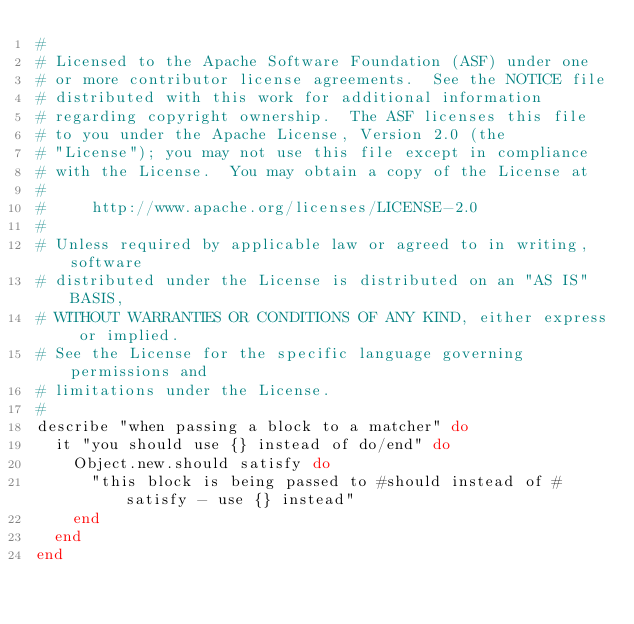<code> <loc_0><loc_0><loc_500><loc_500><_Ruby_>#
# Licensed to the Apache Software Foundation (ASF) under one
# or more contributor license agreements.  See the NOTICE file
# distributed with this work for additional information
# regarding copyright ownership.  The ASF licenses this file
# to you under the Apache License, Version 2.0 (the
# "License"); you may not use this file except in compliance
# with the License.  You may obtain a copy of the License at
#
#     http://www.apache.org/licenses/LICENSE-2.0
#
# Unless required by applicable law or agreed to in writing, software
# distributed under the License is distributed on an "AS IS" BASIS,
# WITHOUT WARRANTIES OR CONDITIONS OF ANY KIND, either express or implied.
# See the License for the specific language governing permissions and
# limitations under the License.
#
describe "when passing a block to a matcher" do
  it "you should use {} instead of do/end" do
    Object.new.should satisfy do
      "this block is being passed to #should instead of #satisfy - use {} instead"
    end
  end
end
</code> 